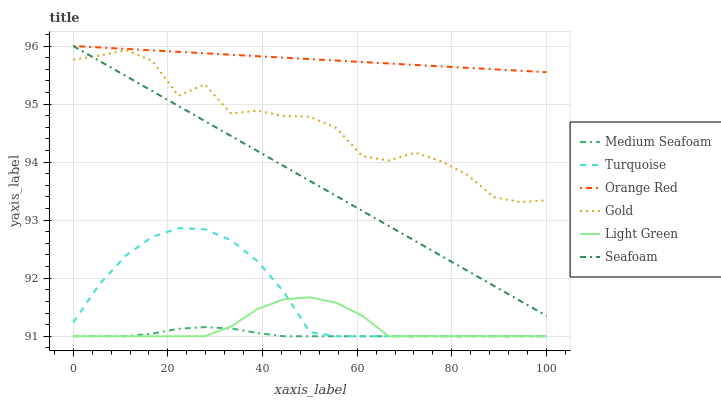Does Medium Seafoam have the minimum area under the curve?
Answer yes or no. Yes. Does Orange Red have the maximum area under the curve?
Answer yes or no. Yes. Does Gold have the minimum area under the curve?
Answer yes or no. No. Does Gold have the maximum area under the curve?
Answer yes or no. No. Is Orange Red the smoothest?
Answer yes or no. Yes. Is Gold the roughest?
Answer yes or no. Yes. Is Seafoam the smoothest?
Answer yes or no. No. Is Seafoam the roughest?
Answer yes or no. No. Does Gold have the lowest value?
Answer yes or no. No. Does Orange Red have the highest value?
Answer yes or no. Yes. Does Gold have the highest value?
Answer yes or no. No. Is Turquoise less than Orange Red?
Answer yes or no. Yes. Is Seafoam greater than Medium Seafoam?
Answer yes or no. Yes. Does Turquoise intersect Orange Red?
Answer yes or no. No. 